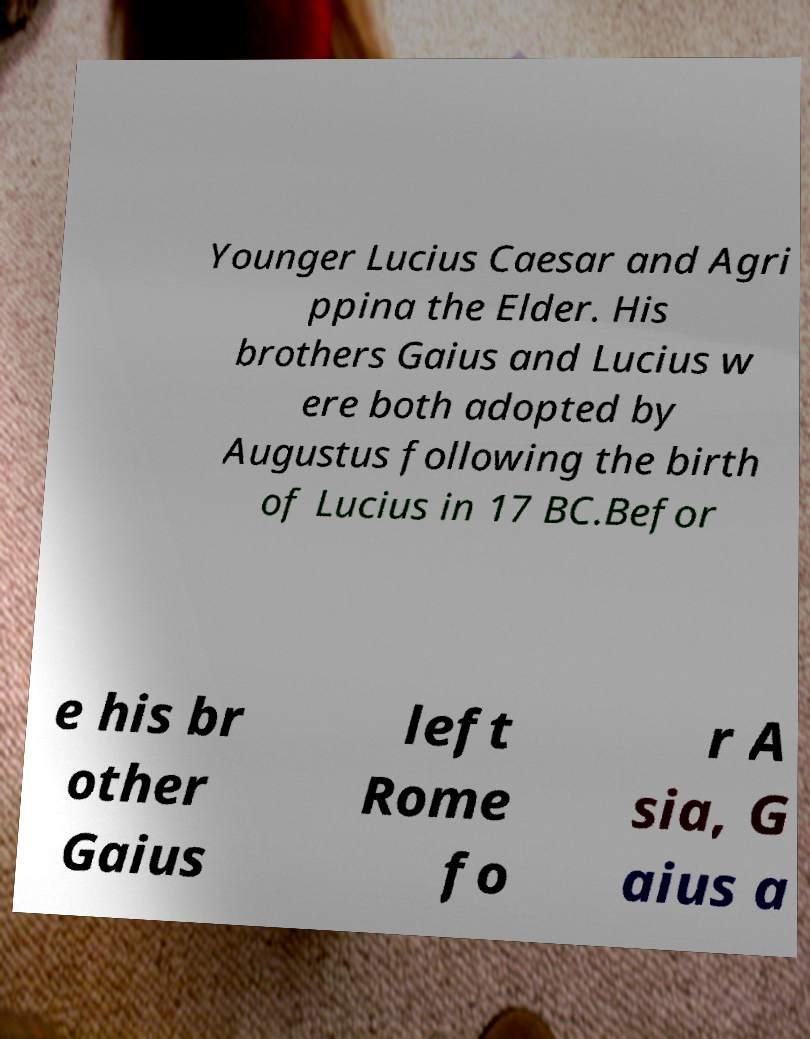Can you accurately transcribe the text from the provided image for me? Younger Lucius Caesar and Agri ppina the Elder. His brothers Gaius and Lucius w ere both adopted by Augustus following the birth of Lucius in 17 BC.Befor e his br other Gaius left Rome fo r A sia, G aius a 